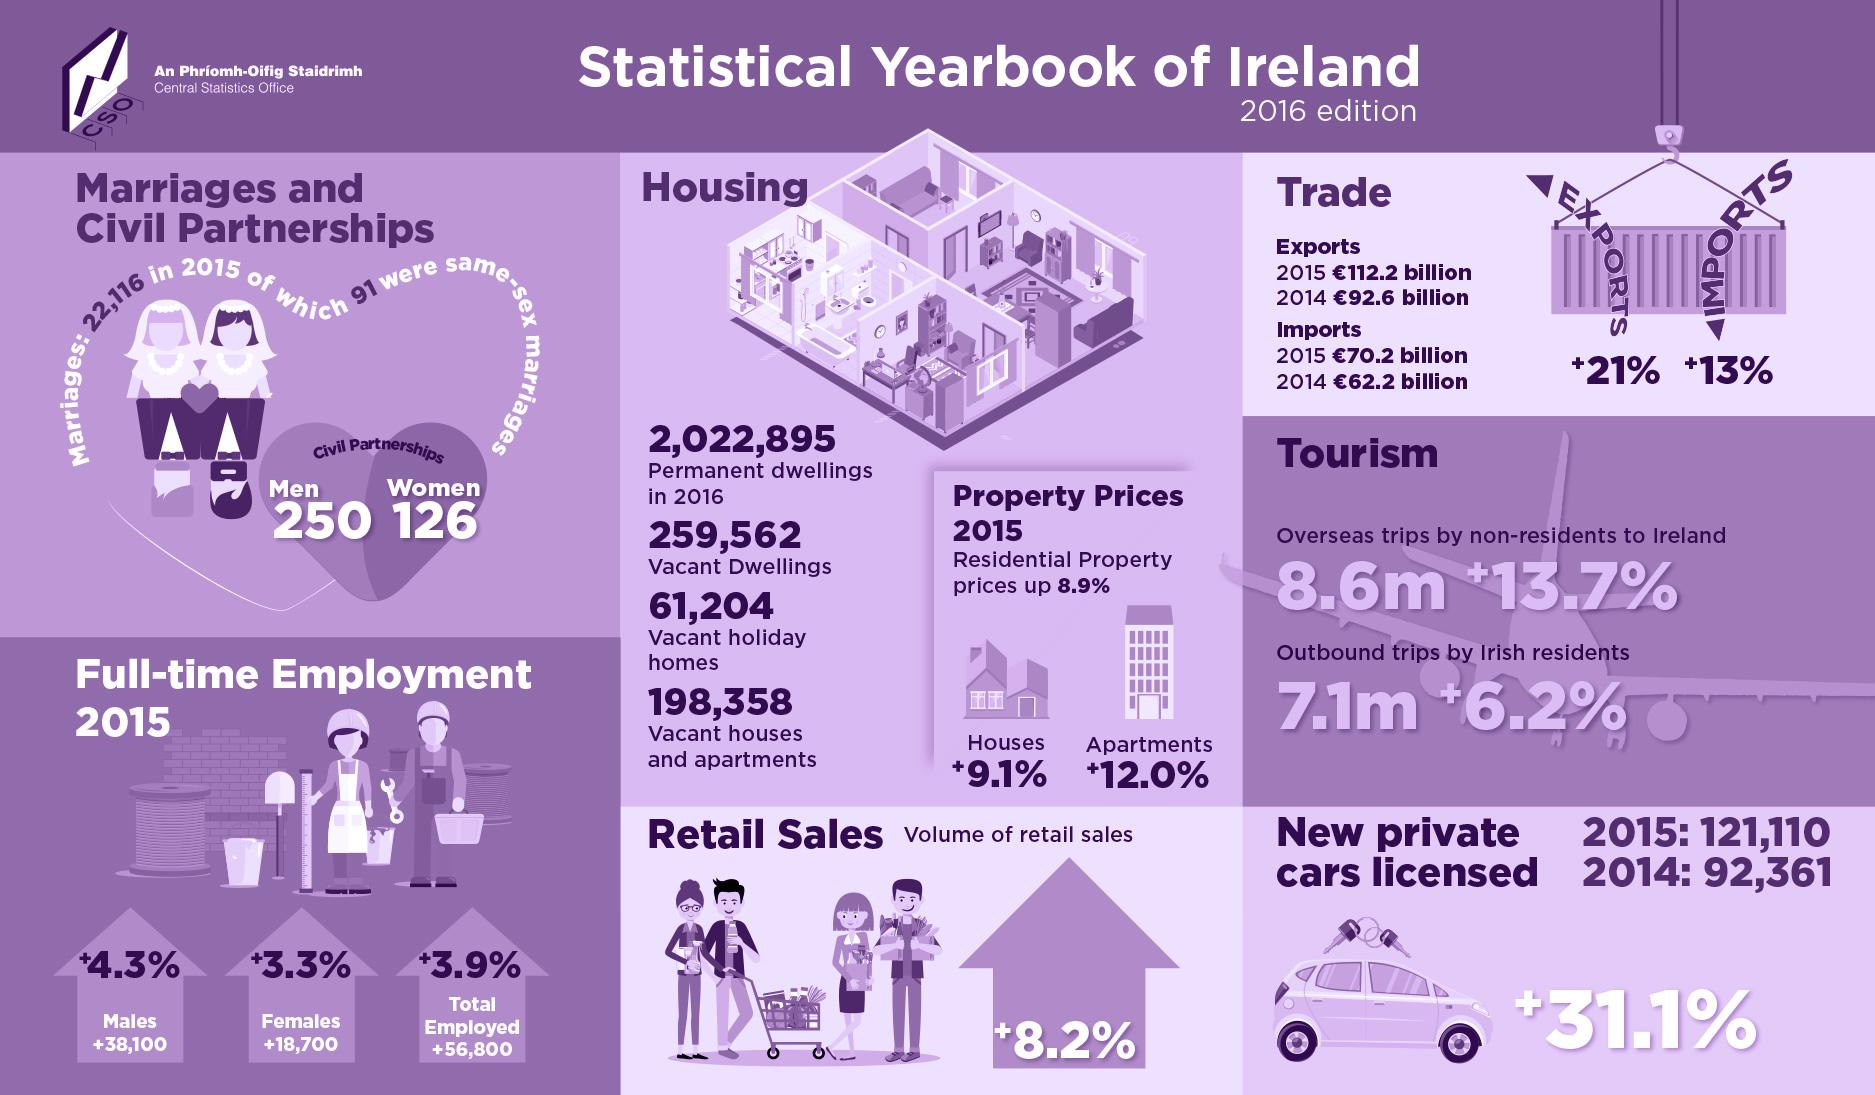Outline some significant characteristics in this image. In 2016, there were approximately 7.1 million outbound trips taken by Irish residents. The percentage increase of full-time female employees in Ireland in 2015 was 3.3%. The increase in the price of residential apartments in Ireland in 2015 was 12.0%. In 2016, a total of 8.6 million overseas trips were taken by non-residents to Ireland. In 2015, the percentage increase in Ireland's imports was +13%. 